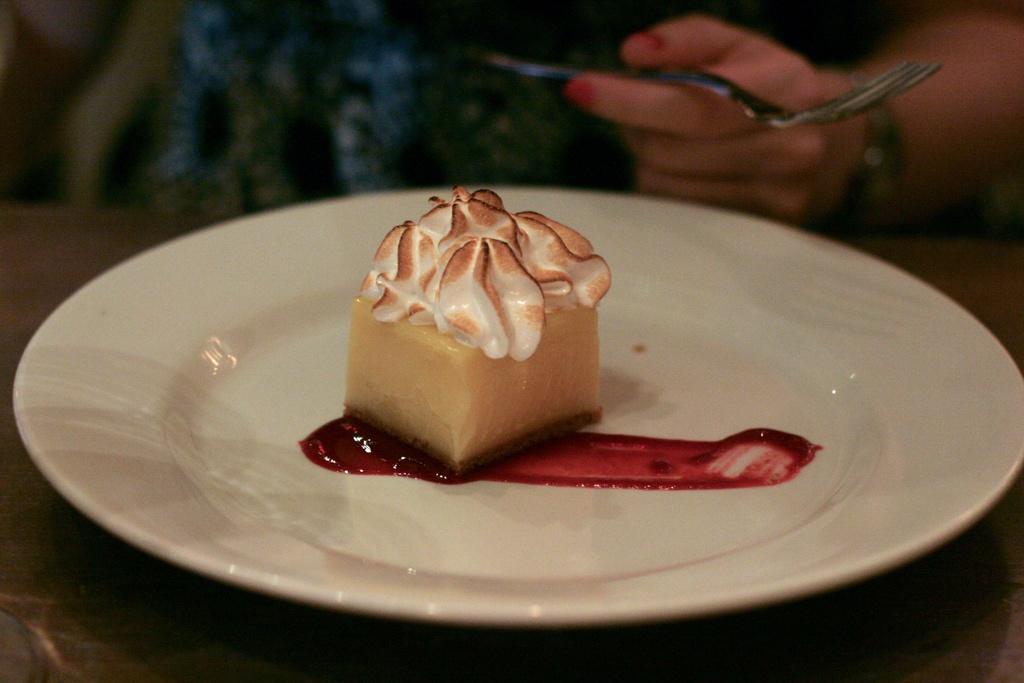How would you summarize this image in a sentence or two? It is a cake in a white color plate, on the right side a human hand is holding a fork. 